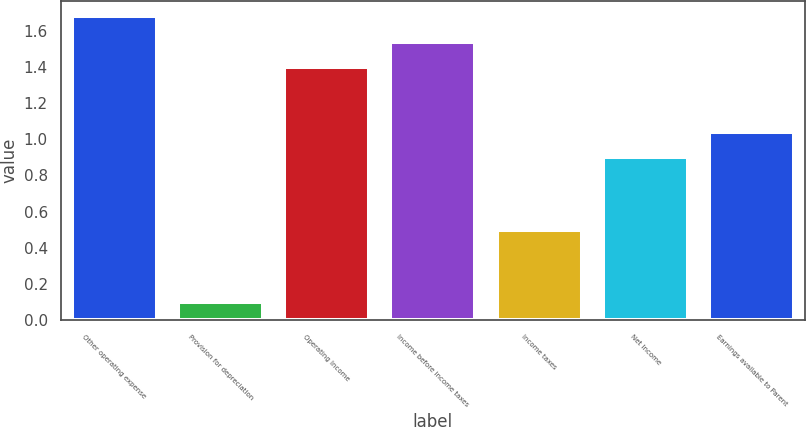Convert chart to OTSL. <chart><loc_0><loc_0><loc_500><loc_500><bar_chart><fcel>Other operating expense<fcel>Provision for depreciation<fcel>Operating Income<fcel>Income before income taxes<fcel>Income taxes<fcel>Net Income<fcel>Earnings available to Parent<nl><fcel>1.68<fcel>0.1<fcel>1.4<fcel>1.54<fcel>0.5<fcel>0.9<fcel>1.04<nl></chart> 